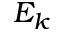Convert formula to latex. <formula><loc_0><loc_0><loc_500><loc_500>E _ { k }</formula> 